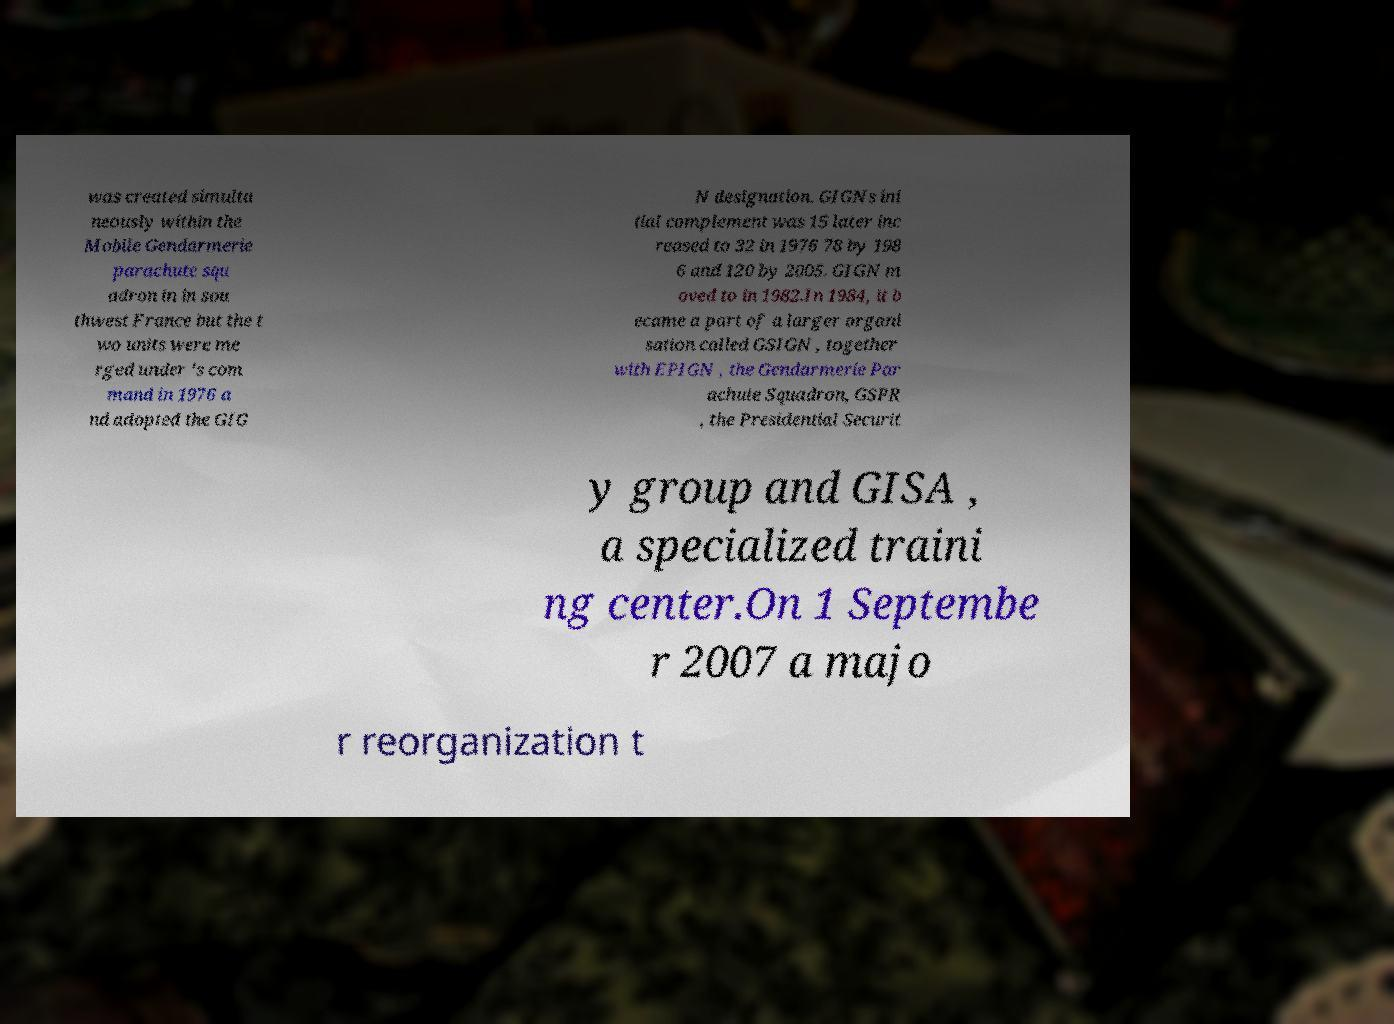There's text embedded in this image that I need extracted. Can you transcribe it verbatim? was created simulta neously within the Mobile Gendarmerie parachute squ adron in in sou thwest France but the t wo units were me rged under 's com mand in 1976 a nd adopted the GIG N designation. GIGNs ini tial complement was 15 later inc reased to 32 in 1976 78 by 198 6 and 120 by 2005. GIGN m oved to in 1982.In 1984, it b ecame a part of a larger organi sation called GSIGN , together with EPIGN , the Gendarmerie Par achute Squadron, GSPR , the Presidential Securit y group and GISA , a specialized traini ng center.On 1 Septembe r 2007 a majo r reorganization t 